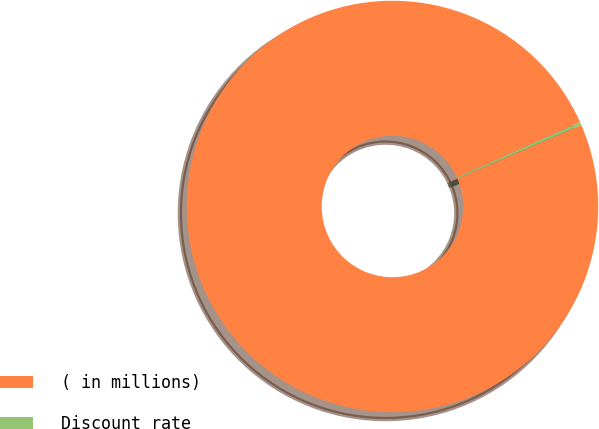Convert chart to OTSL. <chart><loc_0><loc_0><loc_500><loc_500><pie_chart><fcel>( in millions)<fcel>Discount rate<nl><fcel>99.77%<fcel>0.23%<nl></chart> 